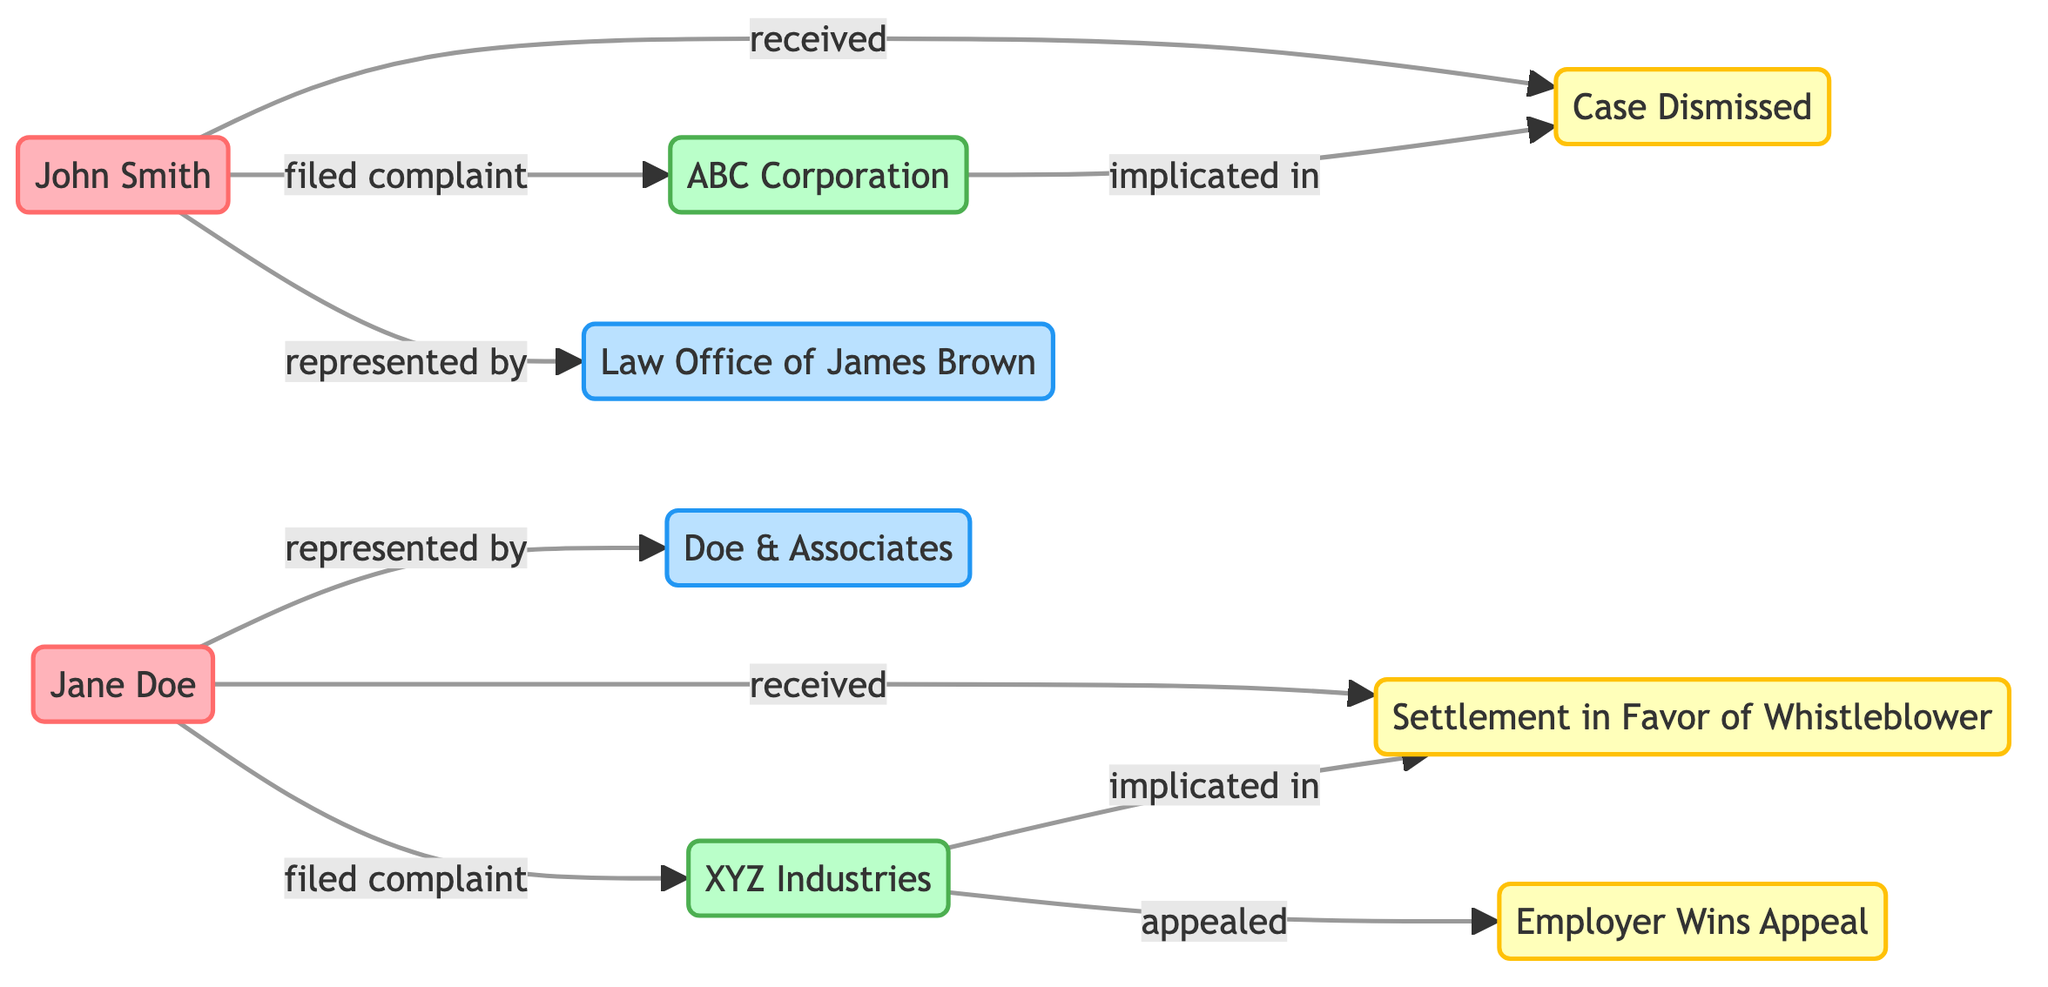What is the total number of whistleblowers represented in the diagram? There are two distinct nodes labeled as whistleblowers: John Smith and Jane Doe. Therefore, by counting them, the total number of whistleblowers is determined to be two.
Answer: 2 Which legal counsel represented John Smith? In the diagram, the link indicates that John Smith is represented by the "Law Office of James Brown." By tracing the link from the whistleblower node to the legal counsel node, we confirm the connection.
Answer: Law Office of James Brown What relationship exists between Jane Doe and XYZ Industries? The diagram shows that Jane Doe filed a complaint against XYZ Industries. This is seen through the directed link pointing from Jane Doe (whistleblower) to XYZ Industries (employer) labeled "filed complaint."
Answer: filed complaint How many total court decisions are shown in the diagram? The diagram lists three distinct court decisions in the nodes section: "Case Dismissed," "Settlement in Favor of Whistleblower," and "Employer Wins Appeal." By counting these, we determine there are three court decisions represented.
Answer: 3 Which employer is implicated in the case dismissed? Referring to the connections in the diagram, ABC Corporation is indicated as the employer implicated in the "Case Dismissed." This is evident through the link from ABC Corporation to the court decision node labeled as "Case Dismissed."
Answer: ABC Corporation What happens after XYZ Industries appeals the court decision? The diagram illustrates that after XYZ Industries appeals, the outcome is labeled as "Employer Wins Appeal." Following the directional link shows a flow from XYZ Industries to this court decision.
Answer: Employer Wins Appeal Which whistleblower received a settlement in their case? In the diagram, Jane Doe is linked to the court decision "Settlement in Favor of Whistleblower.” This connection from her node to the court decision node allows us to identify her as the whistleblower who received a settlement.
Answer: Jane Doe What type of relationship exists between ABC Corporation and the court decision “Case Dismissed”? The relationship type is represented with the label “implicated in” in the link connecting ABC Corporation and the court decision "Case Dismissed." This indicates that ABC Corporation is connected to that particular court decision.
Answer: implicated in Which employer appears first in terms of complaints filed? The directed links from the whistleblower nodes indicate that John Smith first filed a complaint against ABC Corporation before Jane Doe filed hers against XYZ Industries. Hence, ABC Corporation is the first employer in reference to complaints filed.
Answer: ABC Corporation 